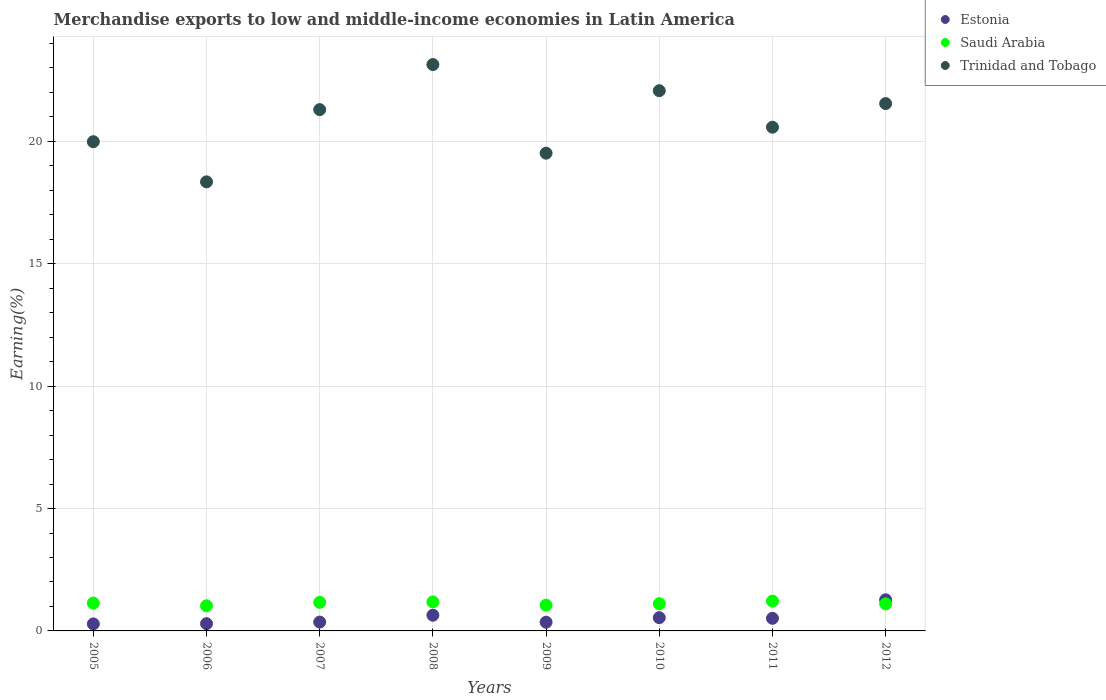How many different coloured dotlines are there?
Your answer should be very brief. 3. Is the number of dotlines equal to the number of legend labels?
Keep it short and to the point. Yes. What is the percentage of amount earned from merchandise exports in Trinidad and Tobago in 2005?
Ensure brevity in your answer.  19.98. Across all years, what is the maximum percentage of amount earned from merchandise exports in Trinidad and Tobago?
Your answer should be very brief. 23.14. Across all years, what is the minimum percentage of amount earned from merchandise exports in Saudi Arabia?
Offer a terse response. 1.03. In which year was the percentage of amount earned from merchandise exports in Estonia minimum?
Provide a succinct answer. 2005. What is the total percentage of amount earned from merchandise exports in Trinidad and Tobago in the graph?
Offer a terse response. 166.46. What is the difference between the percentage of amount earned from merchandise exports in Estonia in 2009 and that in 2012?
Offer a terse response. -0.92. What is the difference between the percentage of amount earned from merchandise exports in Estonia in 2012 and the percentage of amount earned from merchandise exports in Saudi Arabia in 2007?
Offer a very short reply. 0.11. What is the average percentage of amount earned from merchandise exports in Estonia per year?
Offer a very short reply. 0.53. In the year 2012, what is the difference between the percentage of amount earned from merchandise exports in Estonia and percentage of amount earned from merchandise exports in Saudi Arabia?
Provide a succinct answer. 0.17. What is the ratio of the percentage of amount earned from merchandise exports in Trinidad and Tobago in 2009 to that in 2010?
Your response must be concise. 0.88. Is the percentage of amount earned from merchandise exports in Trinidad and Tobago in 2008 less than that in 2011?
Your answer should be very brief. No. What is the difference between the highest and the second highest percentage of amount earned from merchandise exports in Saudi Arabia?
Your answer should be very brief. 0.03. What is the difference between the highest and the lowest percentage of amount earned from merchandise exports in Trinidad and Tobago?
Your response must be concise. 4.79. Is the sum of the percentage of amount earned from merchandise exports in Trinidad and Tobago in 2009 and 2010 greater than the maximum percentage of amount earned from merchandise exports in Saudi Arabia across all years?
Offer a terse response. Yes. Is it the case that in every year, the sum of the percentage of amount earned from merchandise exports in Saudi Arabia and percentage of amount earned from merchandise exports in Trinidad and Tobago  is greater than the percentage of amount earned from merchandise exports in Estonia?
Give a very brief answer. Yes. How many dotlines are there?
Your answer should be compact. 3. How many years are there in the graph?
Give a very brief answer. 8. What is the difference between two consecutive major ticks on the Y-axis?
Your answer should be compact. 5. Are the values on the major ticks of Y-axis written in scientific E-notation?
Offer a terse response. No. How many legend labels are there?
Offer a very short reply. 3. How are the legend labels stacked?
Provide a succinct answer. Vertical. What is the title of the graph?
Ensure brevity in your answer.  Merchandise exports to low and middle-income economies in Latin America. Does "Vanuatu" appear as one of the legend labels in the graph?
Provide a short and direct response. No. What is the label or title of the Y-axis?
Keep it short and to the point. Earning(%). What is the Earning(%) of Estonia in 2005?
Your answer should be compact. 0.29. What is the Earning(%) of Saudi Arabia in 2005?
Offer a terse response. 1.14. What is the Earning(%) of Trinidad and Tobago in 2005?
Provide a succinct answer. 19.98. What is the Earning(%) of Estonia in 2006?
Your answer should be very brief. 0.3. What is the Earning(%) of Saudi Arabia in 2006?
Give a very brief answer. 1.03. What is the Earning(%) of Trinidad and Tobago in 2006?
Give a very brief answer. 18.34. What is the Earning(%) of Estonia in 2007?
Your response must be concise. 0.36. What is the Earning(%) of Saudi Arabia in 2007?
Your response must be concise. 1.17. What is the Earning(%) of Trinidad and Tobago in 2007?
Offer a terse response. 21.29. What is the Earning(%) of Estonia in 2008?
Your response must be concise. 0.64. What is the Earning(%) in Saudi Arabia in 2008?
Keep it short and to the point. 1.19. What is the Earning(%) of Trinidad and Tobago in 2008?
Give a very brief answer. 23.14. What is the Earning(%) in Estonia in 2009?
Provide a succinct answer. 0.36. What is the Earning(%) of Saudi Arabia in 2009?
Provide a short and direct response. 1.05. What is the Earning(%) in Trinidad and Tobago in 2009?
Your response must be concise. 19.52. What is the Earning(%) of Estonia in 2010?
Offer a terse response. 0.54. What is the Earning(%) of Saudi Arabia in 2010?
Provide a succinct answer. 1.11. What is the Earning(%) in Trinidad and Tobago in 2010?
Offer a terse response. 22.07. What is the Earning(%) in Estonia in 2011?
Your answer should be compact. 0.52. What is the Earning(%) in Saudi Arabia in 2011?
Make the answer very short. 1.22. What is the Earning(%) in Trinidad and Tobago in 2011?
Offer a very short reply. 20.58. What is the Earning(%) of Estonia in 2012?
Your response must be concise. 1.27. What is the Earning(%) in Saudi Arabia in 2012?
Provide a short and direct response. 1.11. What is the Earning(%) in Trinidad and Tobago in 2012?
Offer a very short reply. 21.54. Across all years, what is the maximum Earning(%) of Estonia?
Offer a terse response. 1.27. Across all years, what is the maximum Earning(%) in Saudi Arabia?
Your answer should be very brief. 1.22. Across all years, what is the maximum Earning(%) of Trinidad and Tobago?
Offer a terse response. 23.14. Across all years, what is the minimum Earning(%) in Estonia?
Keep it short and to the point. 0.29. Across all years, what is the minimum Earning(%) in Saudi Arabia?
Your answer should be very brief. 1.03. Across all years, what is the minimum Earning(%) of Trinidad and Tobago?
Offer a terse response. 18.34. What is the total Earning(%) in Estonia in the graph?
Give a very brief answer. 4.27. What is the total Earning(%) in Saudi Arabia in the graph?
Your answer should be very brief. 9. What is the total Earning(%) of Trinidad and Tobago in the graph?
Make the answer very short. 166.46. What is the difference between the Earning(%) of Estonia in 2005 and that in 2006?
Your answer should be compact. -0.01. What is the difference between the Earning(%) of Trinidad and Tobago in 2005 and that in 2006?
Your response must be concise. 1.64. What is the difference between the Earning(%) of Estonia in 2005 and that in 2007?
Offer a very short reply. -0.07. What is the difference between the Earning(%) of Saudi Arabia in 2005 and that in 2007?
Provide a succinct answer. -0.03. What is the difference between the Earning(%) in Trinidad and Tobago in 2005 and that in 2007?
Your answer should be compact. -1.31. What is the difference between the Earning(%) in Estonia in 2005 and that in 2008?
Your answer should be compact. -0.35. What is the difference between the Earning(%) of Saudi Arabia in 2005 and that in 2008?
Your answer should be compact. -0.05. What is the difference between the Earning(%) in Trinidad and Tobago in 2005 and that in 2008?
Make the answer very short. -3.15. What is the difference between the Earning(%) in Estonia in 2005 and that in 2009?
Provide a short and direct response. -0.07. What is the difference between the Earning(%) in Saudi Arabia in 2005 and that in 2009?
Your answer should be very brief. 0.09. What is the difference between the Earning(%) of Trinidad and Tobago in 2005 and that in 2009?
Provide a short and direct response. 0.47. What is the difference between the Earning(%) of Estonia in 2005 and that in 2010?
Make the answer very short. -0.25. What is the difference between the Earning(%) in Saudi Arabia in 2005 and that in 2010?
Ensure brevity in your answer.  0.03. What is the difference between the Earning(%) of Trinidad and Tobago in 2005 and that in 2010?
Keep it short and to the point. -2.08. What is the difference between the Earning(%) of Estonia in 2005 and that in 2011?
Offer a very short reply. -0.23. What is the difference between the Earning(%) in Saudi Arabia in 2005 and that in 2011?
Offer a terse response. -0.08. What is the difference between the Earning(%) of Trinidad and Tobago in 2005 and that in 2011?
Offer a terse response. -0.59. What is the difference between the Earning(%) of Estonia in 2005 and that in 2012?
Ensure brevity in your answer.  -0.99. What is the difference between the Earning(%) of Saudi Arabia in 2005 and that in 2012?
Provide a short and direct response. 0.03. What is the difference between the Earning(%) of Trinidad and Tobago in 2005 and that in 2012?
Your response must be concise. -1.56. What is the difference between the Earning(%) of Estonia in 2006 and that in 2007?
Provide a succinct answer. -0.07. What is the difference between the Earning(%) of Saudi Arabia in 2006 and that in 2007?
Offer a terse response. -0.14. What is the difference between the Earning(%) in Trinidad and Tobago in 2006 and that in 2007?
Offer a terse response. -2.95. What is the difference between the Earning(%) of Estonia in 2006 and that in 2008?
Offer a very short reply. -0.35. What is the difference between the Earning(%) of Saudi Arabia in 2006 and that in 2008?
Keep it short and to the point. -0.16. What is the difference between the Earning(%) in Trinidad and Tobago in 2006 and that in 2008?
Your response must be concise. -4.79. What is the difference between the Earning(%) of Estonia in 2006 and that in 2009?
Your response must be concise. -0.06. What is the difference between the Earning(%) in Saudi Arabia in 2006 and that in 2009?
Offer a terse response. -0.03. What is the difference between the Earning(%) in Trinidad and Tobago in 2006 and that in 2009?
Make the answer very short. -1.17. What is the difference between the Earning(%) in Estonia in 2006 and that in 2010?
Keep it short and to the point. -0.25. What is the difference between the Earning(%) in Saudi Arabia in 2006 and that in 2010?
Make the answer very short. -0.09. What is the difference between the Earning(%) of Trinidad and Tobago in 2006 and that in 2010?
Your response must be concise. -3.72. What is the difference between the Earning(%) in Estonia in 2006 and that in 2011?
Ensure brevity in your answer.  -0.22. What is the difference between the Earning(%) in Saudi Arabia in 2006 and that in 2011?
Offer a terse response. -0.19. What is the difference between the Earning(%) of Trinidad and Tobago in 2006 and that in 2011?
Provide a succinct answer. -2.23. What is the difference between the Earning(%) in Estonia in 2006 and that in 2012?
Keep it short and to the point. -0.98. What is the difference between the Earning(%) of Saudi Arabia in 2006 and that in 2012?
Offer a very short reply. -0.08. What is the difference between the Earning(%) in Trinidad and Tobago in 2006 and that in 2012?
Ensure brevity in your answer.  -3.2. What is the difference between the Earning(%) in Estonia in 2007 and that in 2008?
Your answer should be compact. -0.28. What is the difference between the Earning(%) of Saudi Arabia in 2007 and that in 2008?
Give a very brief answer. -0.02. What is the difference between the Earning(%) of Trinidad and Tobago in 2007 and that in 2008?
Ensure brevity in your answer.  -1.84. What is the difference between the Earning(%) of Estonia in 2007 and that in 2009?
Give a very brief answer. 0.01. What is the difference between the Earning(%) in Saudi Arabia in 2007 and that in 2009?
Provide a short and direct response. 0.11. What is the difference between the Earning(%) of Trinidad and Tobago in 2007 and that in 2009?
Keep it short and to the point. 1.78. What is the difference between the Earning(%) of Estonia in 2007 and that in 2010?
Offer a very short reply. -0.18. What is the difference between the Earning(%) of Saudi Arabia in 2007 and that in 2010?
Your answer should be very brief. 0.05. What is the difference between the Earning(%) of Trinidad and Tobago in 2007 and that in 2010?
Your answer should be compact. -0.77. What is the difference between the Earning(%) in Estonia in 2007 and that in 2011?
Provide a short and direct response. -0.15. What is the difference between the Earning(%) in Saudi Arabia in 2007 and that in 2011?
Ensure brevity in your answer.  -0.05. What is the difference between the Earning(%) in Trinidad and Tobago in 2007 and that in 2011?
Keep it short and to the point. 0.72. What is the difference between the Earning(%) of Estonia in 2007 and that in 2012?
Provide a short and direct response. -0.91. What is the difference between the Earning(%) of Saudi Arabia in 2007 and that in 2012?
Your response must be concise. 0.06. What is the difference between the Earning(%) in Trinidad and Tobago in 2007 and that in 2012?
Offer a terse response. -0.25. What is the difference between the Earning(%) of Estonia in 2008 and that in 2009?
Ensure brevity in your answer.  0.29. What is the difference between the Earning(%) in Saudi Arabia in 2008 and that in 2009?
Provide a succinct answer. 0.13. What is the difference between the Earning(%) in Trinidad and Tobago in 2008 and that in 2009?
Offer a terse response. 3.62. What is the difference between the Earning(%) of Estonia in 2008 and that in 2010?
Your answer should be compact. 0.1. What is the difference between the Earning(%) in Saudi Arabia in 2008 and that in 2010?
Provide a succinct answer. 0.07. What is the difference between the Earning(%) of Trinidad and Tobago in 2008 and that in 2010?
Your response must be concise. 1.07. What is the difference between the Earning(%) of Estonia in 2008 and that in 2011?
Your answer should be compact. 0.13. What is the difference between the Earning(%) in Saudi Arabia in 2008 and that in 2011?
Provide a short and direct response. -0.03. What is the difference between the Earning(%) in Trinidad and Tobago in 2008 and that in 2011?
Provide a succinct answer. 2.56. What is the difference between the Earning(%) in Estonia in 2008 and that in 2012?
Provide a short and direct response. -0.63. What is the difference between the Earning(%) of Saudi Arabia in 2008 and that in 2012?
Keep it short and to the point. 0.08. What is the difference between the Earning(%) of Trinidad and Tobago in 2008 and that in 2012?
Provide a succinct answer. 1.59. What is the difference between the Earning(%) of Estonia in 2009 and that in 2010?
Your answer should be very brief. -0.19. What is the difference between the Earning(%) of Saudi Arabia in 2009 and that in 2010?
Your answer should be compact. -0.06. What is the difference between the Earning(%) of Trinidad and Tobago in 2009 and that in 2010?
Provide a short and direct response. -2.55. What is the difference between the Earning(%) of Estonia in 2009 and that in 2011?
Keep it short and to the point. -0.16. What is the difference between the Earning(%) of Saudi Arabia in 2009 and that in 2011?
Your response must be concise. -0.17. What is the difference between the Earning(%) in Trinidad and Tobago in 2009 and that in 2011?
Give a very brief answer. -1.06. What is the difference between the Earning(%) in Estonia in 2009 and that in 2012?
Ensure brevity in your answer.  -0.92. What is the difference between the Earning(%) of Saudi Arabia in 2009 and that in 2012?
Your answer should be very brief. -0.05. What is the difference between the Earning(%) of Trinidad and Tobago in 2009 and that in 2012?
Your answer should be compact. -2.03. What is the difference between the Earning(%) in Estonia in 2010 and that in 2011?
Your answer should be compact. 0.03. What is the difference between the Earning(%) in Saudi Arabia in 2010 and that in 2011?
Give a very brief answer. -0.11. What is the difference between the Earning(%) in Trinidad and Tobago in 2010 and that in 2011?
Make the answer very short. 1.49. What is the difference between the Earning(%) in Estonia in 2010 and that in 2012?
Your response must be concise. -0.73. What is the difference between the Earning(%) in Saudi Arabia in 2010 and that in 2012?
Your answer should be very brief. 0.01. What is the difference between the Earning(%) of Trinidad and Tobago in 2010 and that in 2012?
Your answer should be very brief. 0.53. What is the difference between the Earning(%) of Estonia in 2011 and that in 2012?
Make the answer very short. -0.76. What is the difference between the Earning(%) of Saudi Arabia in 2011 and that in 2012?
Provide a short and direct response. 0.11. What is the difference between the Earning(%) of Trinidad and Tobago in 2011 and that in 2012?
Your answer should be compact. -0.97. What is the difference between the Earning(%) in Estonia in 2005 and the Earning(%) in Saudi Arabia in 2006?
Your answer should be very brief. -0.74. What is the difference between the Earning(%) of Estonia in 2005 and the Earning(%) of Trinidad and Tobago in 2006?
Ensure brevity in your answer.  -18.06. What is the difference between the Earning(%) in Saudi Arabia in 2005 and the Earning(%) in Trinidad and Tobago in 2006?
Your response must be concise. -17.21. What is the difference between the Earning(%) of Estonia in 2005 and the Earning(%) of Saudi Arabia in 2007?
Give a very brief answer. -0.88. What is the difference between the Earning(%) of Estonia in 2005 and the Earning(%) of Trinidad and Tobago in 2007?
Provide a succinct answer. -21.01. What is the difference between the Earning(%) in Saudi Arabia in 2005 and the Earning(%) in Trinidad and Tobago in 2007?
Keep it short and to the point. -20.16. What is the difference between the Earning(%) in Estonia in 2005 and the Earning(%) in Saudi Arabia in 2008?
Give a very brief answer. -0.9. What is the difference between the Earning(%) in Estonia in 2005 and the Earning(%) in Trinidad and Tobago in 2008?
Ensure brevity in your answer.  -22.85. What is the difference between the Earning(%) of Saudi Arabia in 2005 and the Earning(%) of Trinidad and Tobago in 2008?
Offer a very short reply. -22. What is the difference between the Earning(%) of Estonia in 2005 and the Earning(%) of Saudi Arabia in 2009?
Your response must be concise. -0.77. What is the difference between the Earning(%) of Estonia in 2005 and the Earning(%) of Trinidad and Tobago in 2009?
Offer a terse response. -19.23. What is the difference between the Earning(%) of Saudi Arabia in 2005 and the Earning(%) of Trinidad and Tobago in 2009?
Make the answer very short. -18.38. What is the difference between the Earning(%) in Estonia in 2005 and the Earning(%) in Saudi Arabia in 2010?
Provide a short and direct response. -0.83. What is the difference between the Earning(%) in Estonia in 2005 and the Earning(%) in Trinidad and Tobago in 2010?
Make the answer very short. -21.78. What is the difference between the Earning(%) in Saudi Arabia in 2005 and the Earning(%) in Trinidad and Tobago in 2010?
Offer a very short reply. -20.93. What is the difference between the Earning(%) of Estonia in 2005 and the Earning(%) of Saudi Arabia in 2011?
Ensure brevity in your answer.  -0.93. What is the difference between the Earning(%) of Estonia in 2005 and the Earning(%) of Trinidad and Tobago in 2011?
Your response must be concise. -20.29. What is the difference between the Earning(%) in Saudi Arabia in 2005 and the Earning(%) in Trinidad and Tobago in 2011?
Keep it short and to the point. -19.44. What is the difference between the Earning(%) of Estonia in 2005 and the Earning(%) of Saudi Arabia in 2012?
Give a very brief answer. -0.82. What is the difference between the Earning(%) in Estonia in 2005 and the Earning(%) in Trinidad and Tobago in 2012?
Offer a terse response. -21.26. What is the difference between the Earning(%) of Saudi Arabia in 2005 and the Earning(%) of Trinidad and Tobago in 2012?
Offer a terse response. -20.41. What is the difference between the Earning(%) in Estonia in 2006 and the Earning(%) in Saudi Arabia in 2007?
Make the answer very short. -0.87. What is the difference between the Earning(%) in Estonia in 2006 and the Earning(%) in Trinidad and Tobago in 2007?
Your response must be concise. -21. What is the difference between the Earning(%) of Saudi Arabia in 2006 and the Earning(%) of Trinidad and Tobago in 2007?
Provide a succinct answer. -20.27. What is the difference between the Earning(%) of Estonia in 2006 and the Earning(%) of Saudi Arabia in 2008?
Make the answer very short. -0.89. What is the difference between the Earning(%) in Estonia in 2006 and the Earning(%) in Trinidad and Tobago in 2008?
Ensure brevity in your answer.  -22.84. What is the difference between the Earning(%) of Saudi Arabia in 2006 and the Earning(%) of Trinidad and Tobago in 2008?
Offer a very short reply. -22.11. What is the difference between the Earning(%) in Estonia in 2006 and the Earning(%) in Saudi Arabia in 2009?
Offer a very short reply. -0.76. What is the difference between the Earning(%) in Estonia in 2006 and the Earning(%) in Trinidad and Tobago in 2009?
Provide a succinct answer. -19.22. What is the difference between the Earning(%) in Saudi Arabia in 2006 and the Earning(%) in Trinidad and Tobago in 2009?
Your answer should be very brief. -18.49. What is the difference between the Earning(%) of Estonia in 2006 and the Earning(%) of Saudi Arabia in 2010?
Your response must be concise. -0.82. What is the difference between the Earning(%) of Estonia in 2006 and the Earning(%) of Trinidad and Tobago in 2010?
Provide a succinct answer. -21.77. What is the difference between the Earning(%) in Saudi Arabia in 2006 and the Earning(%) in Trinidad and Tobago in 2010?
Your answer should be compact. -21.04. What is the difference between the Earning(%) of Estonia in 2006 and the Earning(%) of Saudi Arabia in 2011?
Offer a terse response. -0.92. What is the difference between the Earning(%) in Estonia in 2006 and the Earning(%) in Trinidad and Tobago in 2011?
Ensure brevity in your answer.  -20.28. What is the difference between the Earning(%) in Saudi Arabia in 2006 and the Earning(%) in Trinidad and Tobago in 2011?
Your answer should be compact. -19.55. What is the difference between the Earning(%) in Estonia in 2006 and the Earning(%) in Saudi Arabia in 2012?
Provide a succinct answer. -0.81. What is the difference between the Earning(%) of Estonia in 2006 and the Earning(%) of Trinidad and Tobago in 2012?
Make the answer very short. -21.25. What is the difference between the Earning(%) of Saudi Arabia in 2006 and the Earning(%) of Trinidad and Tobago in 2012?
Give a very brief answer. -20.52. What is the difference between the Earning(%) in Estonia in 2007 and the Earning(%) in Saudi Arabia in 2008?
Offer a very short reply. -0.82. What is the difference between the Earning(%) of Estonia in 2007 and the Earning(%) of Trinidad and Tobago in 2008?
Keep it short and to the point. -22.78. What is the difference between the Earning(%) of Saudi Arabia in 2007 and the Earning(%) of Trinidad and Tobago in 2008?
Provide a short and direct response. -21.97. What is the difference between the Earning(%) in Estonia in 2007 and the Earning(%) in Saudi Arabia in 2009?
Provide a succinct answer. -0.69. What is the difference between the Earning(%) of Estonia in 2007 and the Earning(%) of Trinidad and Tobago in 2009?
Offer a terse response. -19.15. What is the difference between the Earning(%) of Saudi Arabia in 2007 and the Earning(%) of Trinidad and Tobago in 2009?
Offer a very short reply. -18.35. What is the difference between the Earning(%) in Estonia in 2007 and the Earning(%) in Saudi Arabia in 2010?
Your answer should be compact. -0.75. What is the difference between the Earning(%) of Estonia in 2007 and the Earning(%) of Trinidad and Tobago in 2010?
Offer a terse response. -21.71. What is the difference between the Earning(%) in Saudi Arabia in 2007 and the Earning(%) in Trinidad and Tobago in 2010?
Ensure brevity in your answer.  -20.9. What is the difference between the Earning(%) in Estonia in 2007 and the Earning(%) in Saudi Arabia in 2011?
Offer a terse response. -0.86. What is the difference between the Earning(%) of Estonia in 2007 and the Earning(%) of Trinidad and Tobago in 2011?
Your response must be concise. -20.22. What is the difference between the Earning(%) of Saudi Arabia in 2007 and the Earning(%) of Trinidad and Tobago in 2011?
Your answer should be compact. -19.41. What is the difference between the Earning(%) in Estonia in 2007 and the Earning(%) in Saudi Arabia in 2012?
Make the answer very short. -0.74. What is the difference between the Earning(%) of Estonia in 2007 and the Earning(%) of Trinidad and Tobago in 2012?
Provide a succinct answer. -21.18. What is the difference between the Earning(%) of Saudi Arabia in 2007 and the Earning(%) of Trinidad and Tobago in 2012?
Your answer should be very brief. -20.38. What is the difference between the Earning(%) of Estonia in 2008 and the Earning(%) of Saudi Arabia in 2009?
Ensure brevity in your answer.  -0.41. What is the difference between the Earning(%) of Estonia in 2008 and the Earning(%) of Trinidad and Tobago in 2009?
Keep it short and to the point. -18.87. What is the difference between the Earning(%) of Saudi Arabia in 2008 and the Earning(%) of Trinidad and Tobago in 2009?
Make the answer very short. -18.33. What is the difference between the Earning(%) of Estonia in 2008 and the Earning(%) of Saudi Arabia in 2010?
Your answer should be very brief. -0.47. What is the difference between the Earning(%) in Estonia in 2008 and the Earning(%) in Trinidad and Tobago in 2010?
Provide a short and direct response. -21.43. What is the difference between the Earning(%) in Saudi Arabia in 2008 and the Earning(%) in Trinidad and Tobago in 2010?
Your answer should be very brief. -20.88. What is the difference between the Earning(%) of Estonia in 2008 and the Earning(%) of Saudi Arabia in 2011?
Give a very brief answer. -0.58. What is the difference between the Earning(%) of Estonia in 2008 and the Earning(%) of Trinidad and Tobago in 2011?
Keep it short and to the point. -19.94. What is the difference between the Earning(%) of Saudi Arabia in 2008 and the Earning(%) of Trinidad and Tobago in 2011?
Your answer should be compact. -19.39. What is the difference between the Earning(%) of Estonia in 2008 and the Earning(%) of Saudi Arabia in 2012?
Your answer should be compact. -0.46. What is the difference between the Earning(%) of Estonia in 2008 and the Earning(%) of Trinidad and Tobago in 2012?
Provide a short and direct response. -20.9. What is the difference between the Earning(%) of Saudi Arabia in 2008 and the Earning(%) of Trinidad and Tobago in 2012?
Keep it short and to the point. -20.36. What is the difference between the Earning(%) in Estonia in 2009 and the Earning(%) in Saudi Arabia in 2010?
Your answer should be very brief. -0.76. What is the difference between the Earning(%) in Estonia in 2009 and the Earning(%) in Trinidad and Tobago in 2010?
Ensure brevity in your answer.  -21.71. What is the difference between the Earning(%) of Saudi Arabia in 2009 and the Earning(%) of Trinidad and Tobago in 2010?
Offer a terse response. -21.02. What is the difference between the Earning(%) of Estonia in 2009 and the Earning(%) of Saudi Arabia in 2011?
Your answer should be very brief. -0.86. What is the difference between the Earning(%) in Estonia in 2009 and the Earning(%) in Trinidad and Tobago in 2011?
Make the answer very short. -20.22. What is the difference between the Earning(%) in Saudi Arabia in 2009 and the Earning(%) in Trinidad and Tobago in 2011?
Provide a short and direct response. -19.52. What is the difference between the Earning(%) of Estonia in 2009 and the Earning(%) of Saudi Arabia in 2012?
Provide a succinct answer. -0.75. What is the difference between the Earning(%) in Estonia in 2009 and the Earning(%) in Trinidad and Tobago in 2012?
Offer a terse response. -21.19. What is the difference between the Earning(%) of Saudi Arabia in 2009 and the Earning(%) of Trinidad and Tobago in 2012?
Provide a succinct answer. -20.49. What is the difference between the Earning(%) of Estonia in 2010 and the Earning(%) of Saudi Arabia in 2011?
Make the answer very short. -0.68. What is the difference between the Earning(%) in Estonia in 2010 and the Earning(%) in Trinidad and Tobago in 2011?
Make the answer very short. -20.04. What is the difference between the Earning(%) of Saudi Arabia in 2010 and the Earning(%) of Trinidad and Tobago in 2011?
Provide a succinct answer. -19.46. What is the difference between the Earning(%) in Estonia in 2010 and the Earning(%) in Saudi Arabia in 2012?
Your response must be concise. -0.56. What is the difference between the Earning(%) of Estonia in 2010 and the Earning(%) of Trinidad and Tobago in 2012?
Your answer should be compact. -21. What is the difference between the Earning(%) of Saudi Arabia in 2010 and the Earning(%) of Trinidad and Tobago in 2012?
Ensure brevity in your answer.  -20.43. What is the difference between the Earning(%) in Estonia in 2011 and the Earning(%) in Saudi Arabia in 2012?
Offer a terse response. -0.59. What is the difference between the Earning(%) in Estonia in 2011 and the Earning(%) in Trinidad and Tobago in 2012?
Offer a terse response. -21.03. What is the difference between the Earning(%) of Saudi Arabia in 2011 and the Earning(%) of Trinidad and Tobago in 2012?
Ensure brevity in your answer.  -20.32. What is the average Earning(%) in Estonia per year?
Your response must be concise. 0.53. What is the average Earning(%) in Saudi Arabia per year?
Provide a succinct answer. 1.13. What is the average Earning(%) in Trinidad and Tobago per year?
Ensure brevity in your answer.  20.81. In the year 2005, what is the difference between the Earning(%) of Estonia and Earning(%) of Saudi Arabia?
Offer a terse response. -0.85. In the year 2005, what is the difference between the Earning(%) in Estonia and Earning(%) in Trinidad and Tobago?
Give a very brief answer. -19.7. In the year 2005, what is the difference between the Earning(%) in Saudi Arabia and Earning(%) in Trinidad and Tobago?
Your answer should be compact. -18.85. In the year 2006, what is the difference between the Earning(%) of Estonia and Earning(%) of Saudi Arabia?
Give a very brief answer. -0.73. In the year 2006, what is the difference between the Earning(%) in Estonia and Earning(%) in Trinidad and Tobago?
Your answer should be very brief. -18.05. In the year 2006, what is the difference between the Earning(%) in Saudi Arabia and Earning(%) in Trinidad and Tobago?
Your answer should be compact. -17.32. In the year 2007, what is the difference between the Earning(%) of Estonia and Earning(%) of Saudi Arabia?
Offer a very short reply. -0.81. In the year 2007, what is the difference between the Earning(%) of Estonia and Earning(%) of Trinidad and Tobago?
Provide a short and direct response. -20.93. In the year 2007, what is the difference between the Earning(%) in Saudi Arabia and Earning(%) in Trinidad and Tobago?
Give a very brief answer. -20.13. In the year 2008, what is the difference between the Earning(%) in Estonia and Earning(%) in Saudi Arabia?
Your answer should be very brief. -0.54. In the year 2008, what is the difference between the Earning(%) of Estonia and Earning(%) of Trinidad and Tobago?
Offer a terse response. -22.49. In the year 2008, what is the difference between the Earning(%) of Saudi Arabia and Earning(%) of Trinidad and Tobago?
Offer a very short reply. -21.95. In the year 2009, what is the difference between the Earning(%) in Estonia and Earning(%) in Saudi Arabia?
Your answer should be compact. -0.7. In the year 2009, what is the difference between the Earning(%) in Estonia and Earning(%) in Trinidad and Tobago?
Your response must be concise. -19.16. In the year 2009, what is the difference between the Earning(%) in Saudi Arabia and Earning(%) in Trinidad and Tobago?
Keep it short and to the point. -18.46. In the year 2010, what is the difference between the Earning(%) of Estonia and Earning(%) of Saudi Arabia?
Provide a succinct answer. -0.57. In the year 2010, what is the difference between the Earning(%) of Estonia and Earning(%) of Trinidad and Tobago?
Offer a terse response. -21.53. In the year 2010, what is the difference between the Earning(%) of Saudi Arabia and Earning(%) of Trinidad and Tobago?
Give a very brief answer. -20.96. In the year 2011, what is the difference between the Earning(%) in Estonia and Earning(%) in Saudi Arabia?
Make the answer very short. -0.7. In the year 2011, what is the difference between the Earning(%) in Estonia and Earning(%) in Trinidad and Tobago?
Your answer should be very brief. -20.06. In the year 2011, what is the difference between the Earning(%) in Saudi Arabia and Earning(%) in Trinidad and Tobago?
Provide a succinct answer. -19.36. In the year 2012, what is the difference between the Earning(%) of Estonia and Earning(%) of Saudi Arabia?
Give a very brief answer. 0.17. In the year 2012, what is the difference between the Earning(%) of Estonia and Earning(%) of Trinidad and Tobago?
Offer a terse response. -20.27. In the year 2012, what is the difference between the Earning(%) of Saudi Arabia and Earning(%) of Trinidad and Tobago?
Offer a terse response. -20.44. What is the ratio of the Earning(%) of Estonia in 2005 to that in 2006?
Ensure brevity in your answer.  0.97. What is the ratio of the Earning(%) of Saudi Arabia in 2005 to that in 2006?
Ensure brevity in your answer.  1.11. What is the ratio of the Earning(%) of Trinidad and Tobago in 2005 to that in 2006?
Provide a short and direct response. 1.09. What is the ratio of the Earning(%) in Estonia in 2005 to that in 2007?
Make the answer very short. 0.79. What is the ratio of the Earning(%) of Saudi Arabia in 2005 to that in 2007?
Your response must be concise. 0.97. What is the ratio of the Earning(%) of Trinidad and Tobago in 2005 to that in 2007?
Provide a short and direct response. 0.94. What is the ratio of the Earning(%) in Estonia in 2005 to that in 2008?
Provide a succinct answer. 0.45. What is the ratio of the Earning(%) in Saudi Arabia in 2005 to that in 2008?
Ensure brevity in your answer.  0.96. What is the ratio of the Earning(%) in Trinidad and Tobago in 2005 to that in 2008?
Give a very brief answer. 0.86. What is the ratio of the Earning(%) in Estonia in 2005 to that in 2009?
Provide a succinct answer. 0.81. What is the ratio of the Earning(%) in Saudi Arabia in 2005 to that in 2009?
Provide a succinct answer. 1.08. What is the ratio of the Earning(%) in Trinidad and Tobago in 2005 to that in 2009?
Provide a succinct answer. 1.02. What is the ratio of the Earning(%) in Estonia in 2005 to that in 2010?
Make the answer very short. 0.53. What is the ratio of the Earning(%) of Saudi Arabia in 2005 to that in 2010?
Provide a succinct answer. 1.02. What is the ratio of the Earning(%) in Trinidad and Tobago in 2005 to that in 2010?
Provide a short and direct response. 0.91. What is the ratio of the Earning(%) of Estonia in 2005 to that in 2011?
Offer a very short reply. 0.56. What is the ratio of the Earning(%) of Saudi Arabia in 2005 to that in 2011?
Offer a very short reply. 0.93. What is the ratio of the Earning(%) in Trinidad and Tobago in 2005 to that in 2011?
Offer a very short reply. 0.97. What is the ratio of the Earning(%) of Estonia in 2005 to that in 2012?
Provide a succinct answer. 0.23. What is the ratio of the Earning(%) of Saudi Arabia in 2005 to that in 2012?
Ensure brevity in your answer.  1.03. What is the ratio of the Earning(%) of Trinidad and Tobago in 2005 to that in 2012?
Your answer should be very brief. 0.93. What is the ratio of the Earning(%) of Estonia in 2006 to that in 2007?
Your answer should be very brief. 0.82. What is the ratio of the Earning(%) of Saudi Arabia in 2006 to that in 2007?
Give a very brief answer. 0.88. What is the ratio of the Earning(%) of Trinidad and Tobago in 2006 to that in 2007?
Offer a very short reply. 0.86. What is the ratio of the Earning(%) of Estonia in 2006 to that in 2008?
Keep it short and to the point. 0.46. What is the ratio of the Earning(%) in Saudi Arabia in 2006 to that in 2008?
Your response must be concise. 0.87. What is the ratio of the Earning(%) of Trinidad and Tobago in 2006 to that in 2008?
Your answer should be very brief. 0.79. What is the ratio of the Earning(%) in Estonia in 2006 to that in 2009?
Provide a short and direct response. 0.83. What is the ratio of the Earning(%) of Saudi Arabia in 2006 to that in 2009?
Make the answer very short. 0.98. What is the ratio of the Earning(%) in Trinidad and Tobago in 2006 to that in 2009?
Provide a short and direct response. 0.94. What is the ratio of the Earning(%) of Estonia in 2006 to that in 2010?
Provide a succinct answer. 0.55. What is the ratio of the Earning(%) of Saudi Arabia in 2006 to that in 2010?
Offer a terse response. 0.92. What is the ratio of the Earning(%) of Trinidad and Tobago in 2006 to that in 2010?
Provide a succinct answer. 0.83. What is the ratio of the Earning(%) of Estonia in 2006 to that in 2011?
Provide a short and direct response. 0.57. What is the ratio of the Earning(%) in Saudi Arabia in 2006 to that in 2011?
Provide a short and direct response. 0.84. What is the ratio of the Earning(%) in Trinidad and Tobago in 2006 to that in 2011?
Your answer should be very brief. 0.89. What is the ratio of the Earning(%) of Estonia in 2006 to that in 2012?
Make the answer very short. 0.23. What is the ratio of the Earning(%) in Saudi Arabia in 2006 to that in 2012?
Offer a terse response. 0.93. What is the ratio of the Earning(%) in Trinidad and Tobago in 2006 to that in 2012?
Your response must be concise. 0.85. What is the ratio of the Earning(%) of Estonia in 2007 to that in 2008?
Offer a terse response. 0.56. What is the ratio of the Earning(%) in Saudi Arabia in 2007 to that in 2008?
Keep it short and to the point. 0.98. What is the ratio of the Earning(%) in Trinidad and Tobago in 2007 to that in 2008?
Keep it short and to the point. 0.92. What is the ratio of the Earning(%) of Estonia in 2007 to that in 2009?
Give a very brief answer. 1.02. What is the ratio of the Earning(%) of Saudi Arabia in 2007 to that in 2009?
Ensure brevity in your answer.  1.11. What is the ratio of the Earning(%) in Trinidad and Tobago in 2007 to that in 2009?
Keep it short and to the point. 1.09. What is the ratio of the Earning(%) of Estonia in 2007 to that in 2010?
Offer a terse response. 0.67. What is the ratio of the Earning(%) in Saudi Arabia in 2007 to that in 2010?
Offer a very short reply. 1.05. What is the ratio of the Earning(%) in Trinidad and Tobago in 2007 to that in 2010?
Your response must be concise. 0.96. What is the ratio of the Earning(%) in Estonia in 2007 to that in 2011?
Offer a very short reply. 0.7. What is the ratio of the Earning(%) of Saudi Arabia in 2007 to that in 2011?
Your answer should be very brief. 0.96. What is the ratio of the Earning(%) of Trinidad and Tobago in 2007 to that in 2011?
Offer a terse response. 1.03. What is the ratio of the Earning(%) in Estonia in 2007 to that in 2012?
Provide a succinct answer. 0.28. What is the ratio of the Earning(%) in Saudi Arabia in 2007 to that in 2012?
Ensure brevity in your answer.  1.05. What is the ratio of the Earning(%) in Estonia in 2008 to that in 2009?
Offer a terse response. 1.8. What is the ratio of the Earning(%) in Saudi Arabia in 2008 to that in 2009?
Provide a short and direct response. 1.13. What is the ratio of the Earning(%) in Trinidad and Tobago in 2008 to that in 2009?
Ensure brevity in your answer.  1.19. What is the ratio of the Earning(%) in Estonia in 2008 to that in 2010?
Give a very brief answer. 1.18. What is the ratio of the Earning(%) in Saudi Arabia in 2008 to that in 2010?
Your answer should be very brief. 1.07. What is the ratio of the Earning(%) of Trinidad and Tobago in 2008 to that in 2010?
Offer a terse response. 1.05. What is the ratio of the Earning(%) in Estonia in 2008 to that in 2011?
Your response must be concise. 1.24. What is the ratio of the Earning(%) of Saudi Arabia in 2008 to that in 2011?
Provide a succinct answer. 0.97. What is the ratio of the Earning(%) in Trinidad and Tobago in 2008 to that in 2011?
Keep it short and to the point. 1.12. What is the ratio of the Earning(%) in Estonia in 2008 to that in 2012?
Offer a terse response. 0.5. What is the ratio of the Earning(%) of Saudi Arabia in 2008 to that in 2012?
Offer a terse response. 1.07. What is the ratio of the Earning(%) of Trinidad and Tobago in 2008 to that in 2012?
Your response must be concise. 1.07. What is the ratio of the Earning(%) of Estonia in 2009 to that in 2010?
Keep it short and to the point. 0.66. What is the ratio of the Earning(%) in Saudi Arabia in 2009 to that in 2010?
Offer a very short reply. 0.95. What is the ratio of the Earning(%) in Trinidad and Tobago in 2009 to that in 2010?
Ensure brevity in your answer.  0.88. What is the ratio of the Earning(%) of Estonia in 2009 to that in 2011?
Your answer should be very brief. 0.69. What is the ratio of the Earning(%) in Saudi Arabia in 2009 to that in 2011?
Provide a succinct answer. 0.86. What is the ratio of the Earning(%) in Trinidad and Tobago in 2009 to that in 2011?
Ensure brevity in your answer.  0.95. What is the ratio of the Earning(%) of Estonia in 2009 to that in 2012?
Provide a short and direct response. 0.28. What is the ratio of the Earning(%) of Saudi Arabia in 2009 to that in 2012?
Make the answer very short. 0.95. What is the ratio of the Earning(%) of Trinidad and Tobago in 2009 to that in 2012?
Provide a succinct answer. 0.91. What is the ratio of the Earning(%) of Estonia in 2010 to that in 2011?
Offer a very short reply. 1.05. What is the ratio of the Earning(%) in Saudi Arabia in 2010 to that in 2011?
Your answer should be very brief. 0.91. What is the ratio of the Earning(%) in Trinidad and Tobago in 2010 to that in 2011?
Offer a very short reply. 1.07. What is the ratio of the Earning(%) of Estonia in 2010 to that in 2012?
Your answer should be very brief. 0.43. What is the ratio of the Earning(%) of Trinidad and Tobago in 2010 to that in 2012?
Make the answer very short. 1.02. What is the ratio of the Earning(%) in Estonia in 2011 to that in 2012?
Your answer should be compact. 0.41. What is the ratio of the Earning(%) in Saudi Arabia in 2011 to that in 2012?
Offer a terse response. 1.1. What is the ratio of the Earning(%) in Trinidad and Tobago in 2011 to that in 2012?
Keep it short and to the point. 0.96. What is the difference between the highest and the second highest Earning(%) in Estonia?
Provide a short and direct response. 0.63. What is the difference between the highest and the second highest Earning(%) in Saudi Arabia?
Keep it short and to the point. 0.03. What is the difference between the highest and the second highest Earning(%) in Trinidad and Tobago?
Ensure brevity in your answer.  1.07. What is the difference between the highest and the lowest Earning(%) in Estonia?
Ensure brevity in your answer.  0.99. What is the difference between the highest and the lowest Earning(%) of Saudi Arabia?
Your answer should be compact. 0.19. What is the difference between the highest and the lowest Earning(%) in Trinidad and Tobago?
Your response must be concise. 4.79. 